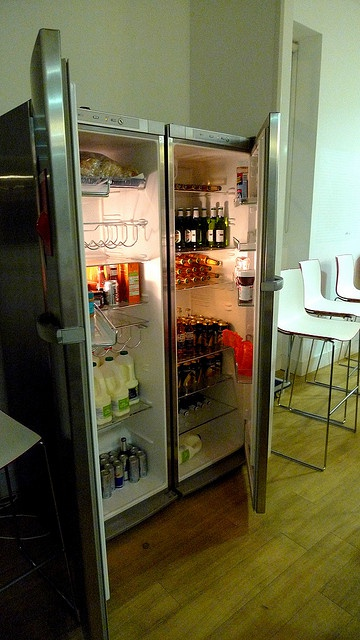Describe the objects in this image and their specific colors. I can see refrigerator in gray, black, olive, and tan tones, chair in gray, black, and darkgreen tones, chair in gray, olive, and beige tones, bottle in gray, black, olive, and maroon tones, and chair in gray, ivory, black, darkgray, and maroon tones in this image. 